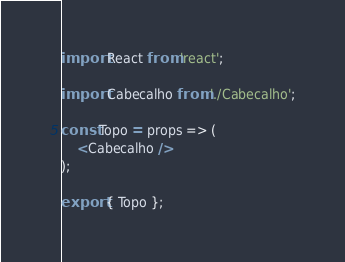<code> <loc_0><loc_0><loc_500><loc_500><_JavaScript_>import React from 'react';

import Cabecalho from './Cabecalho';

const Topo = props => (
    <Cabecalho />
);

export { Topo };
</code> 